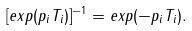Convert formula to latex. <formula><loc_0><loc_0><loc_500><loc_500>[ e x p ( p _ { i } T _ { i } ) ] ^ { - 1 } = e x p ( - p _ { i } T _ { i } ) .</formula> 